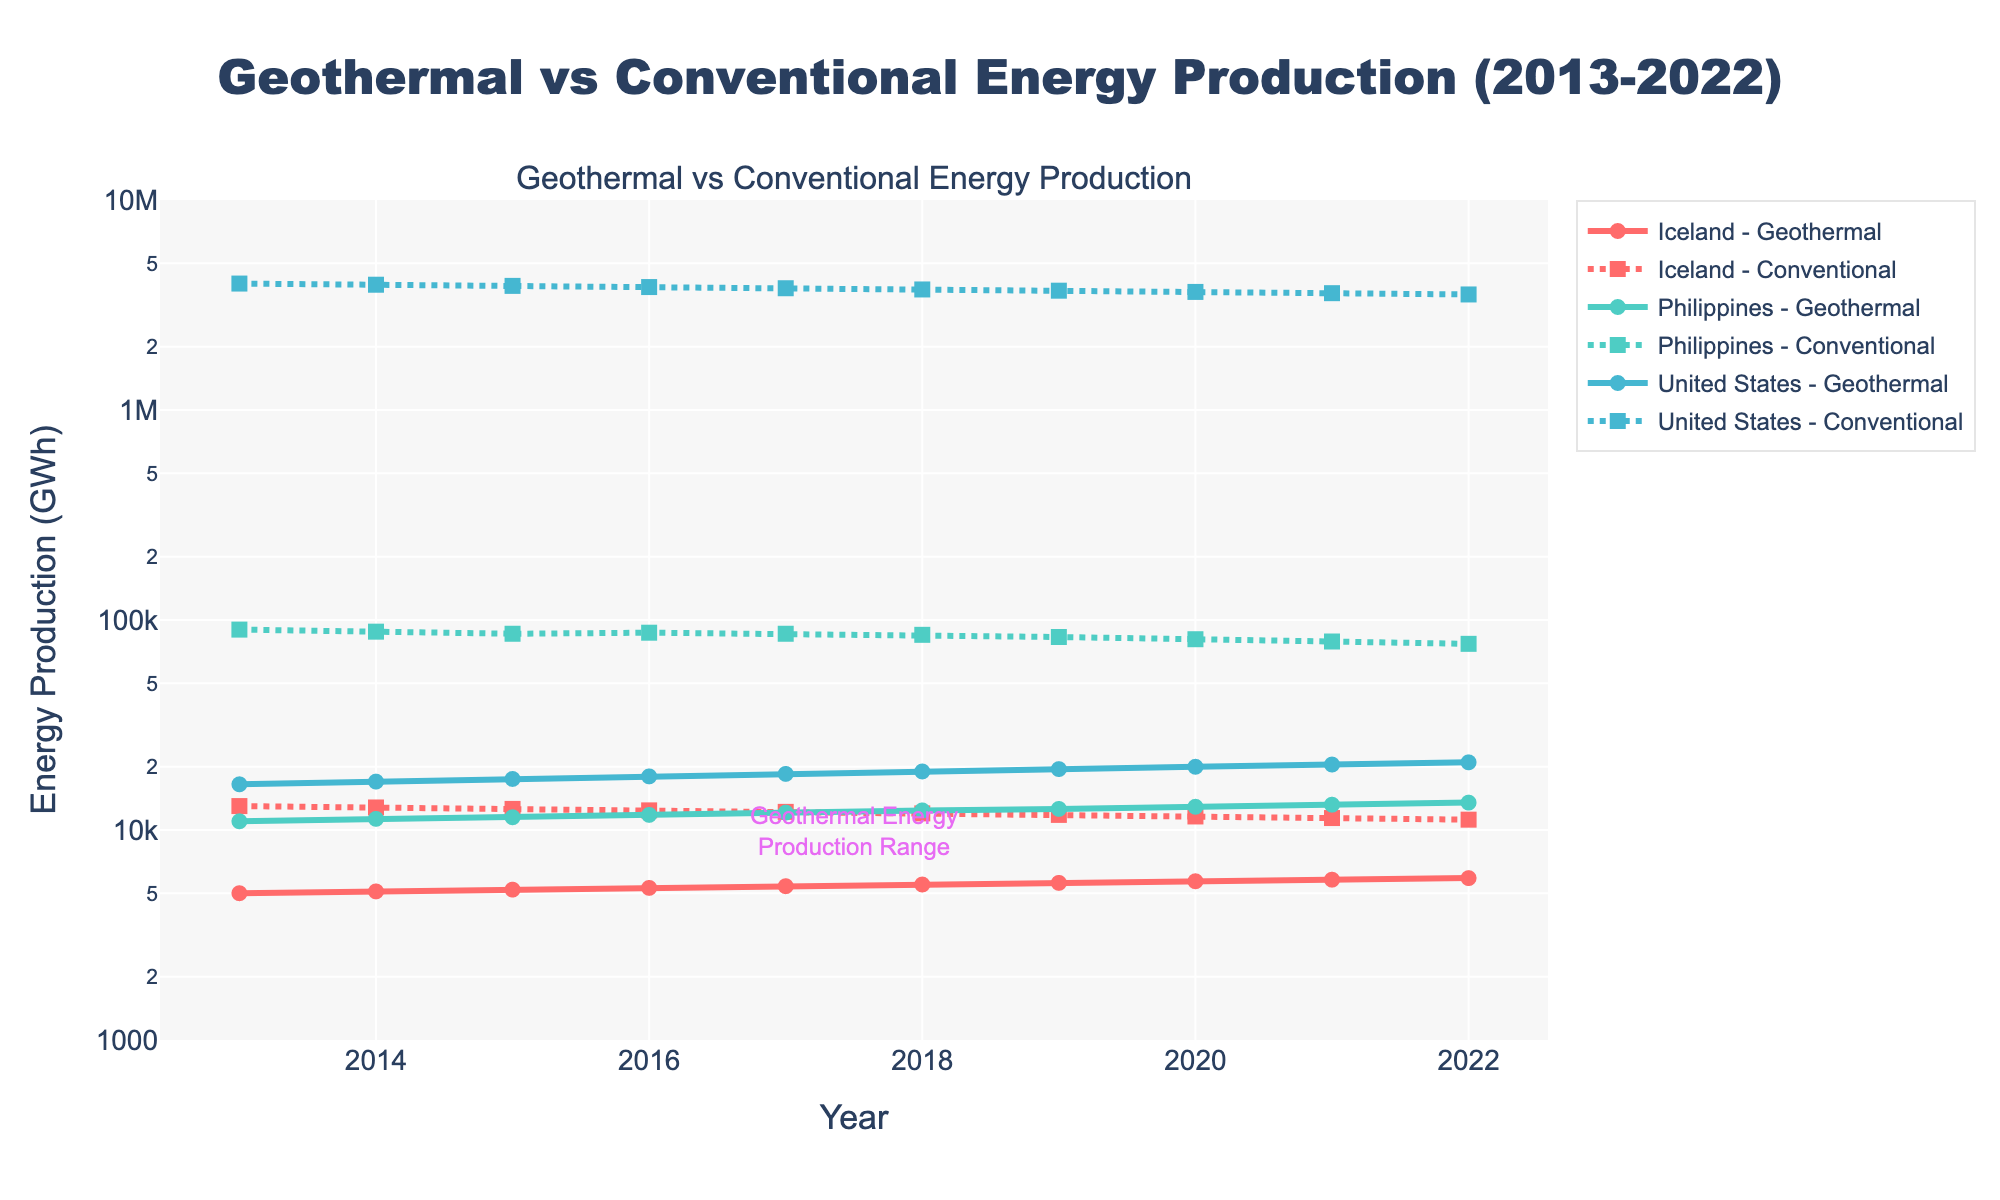What does the title of the figure say? The title is located at the top center of the figure. It reads "Geothermal vs Conventional Energy Production (2013-2022)" clearly highlighting the focus on comparing these energy sources over the given time span.
Answer: Geothermal vs Conventional Energy Production (2013-2022) Which region has the highest geothermal energy production in 2022? By looking at the end of the geothermal energy production lines for each region in 2022, we see that the United States has the highest value.
Answer: United States What is the relationship between geothermal and conventional energy production in Iceland in 2018? In 2018, the line for geothermal energy production intersects the point approximately at 5500 GWh, whereas the line for conventional energy production intersects at around 12000 GWh, indicating that conventional energy production is higher.
Answer: Conventional energy production is higher What is the trend in geothermal energy production in the Philippines from 2013 to 2022? Observing the dashed line representing the geothermal energy production in the Philippines, it shows a steadily increasing trend from 2013 to 2022.
Answer: Increasing Compare the conventional energy production in Iceland to the Philippines in 2020. Which one is lesser? By examining the values on the y-axis for 2020, Iceland's conventional energy production is about 11600 GWh, while the Philippines' is around 81000 GWh. Hence, Iceland's value is lesser.
Answer: Iceland What is the average geothermal energy production in the United States from 2013 to 2022? Sum the yearly geothermal energy production in the United States over the decade (16500 + 17000 + 17500 + 18000 + 18500 + 19000 + 19500 + 20000 + 20500 + 21000) and divide by the number of years (10). (165500 GWh / 10) = 16550 GWh
Answer: 18500 GWh Compare the general trend of conventional energy production in the Philippines and Iceland from 2013 to 2022. Both lines show a declining trend, but Iceland’s decline is more gradual, while the Philippines shows a more rapid decrease.
Answer: Both are declining, the Philippines more sharply Between which years did geothermal energy production in the United States first surpass 20000 GWh? Observing the trend line for the United States, it is clear that geothermal energy production surpasses 20000 GWh between 2020 and 2021.
Answer: 2020 and 2021 What is the log scale range set for the y-axis in the figure? The y-axis of the figure is set to a log scale with the range specified from 3 to 7, as indicated in the plot settings.
Answer: 3 to 7 